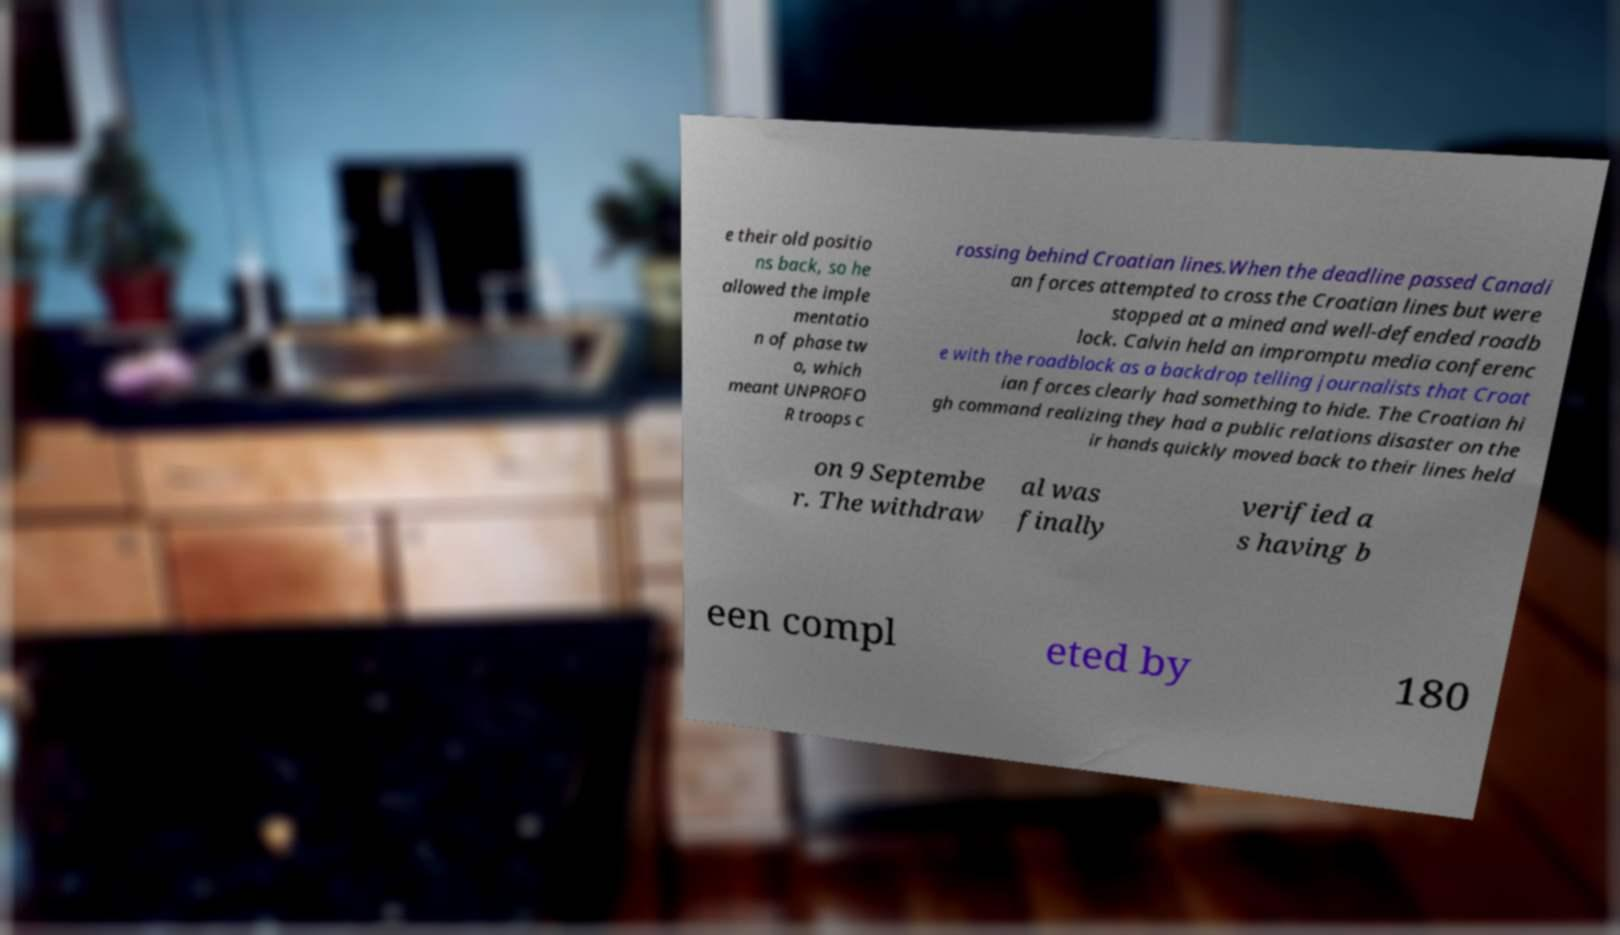I need the written content from this picture converted into text. Can you do that? e their old positio ns back, so he allowed the imple mentatio n of phase tw o, which meant UNPROFO R troops c rossing behind Croatian lines.When the deadline passed Canadi an forces attempted to cross the Croatian lines but were stopped at a mined and well-defended roadb lock. Calvin held an impromptu media conferenc e with the roadblock as a backdrop telling journalists that Croat ian forces clearly had something to hide. The Croatian hi gh command realizing they had a public relations disaster on the ir hands quickly moved back to their lines held on 9 Septembe r. The withdraw al was finally verified a s having b een compl eted by 180 